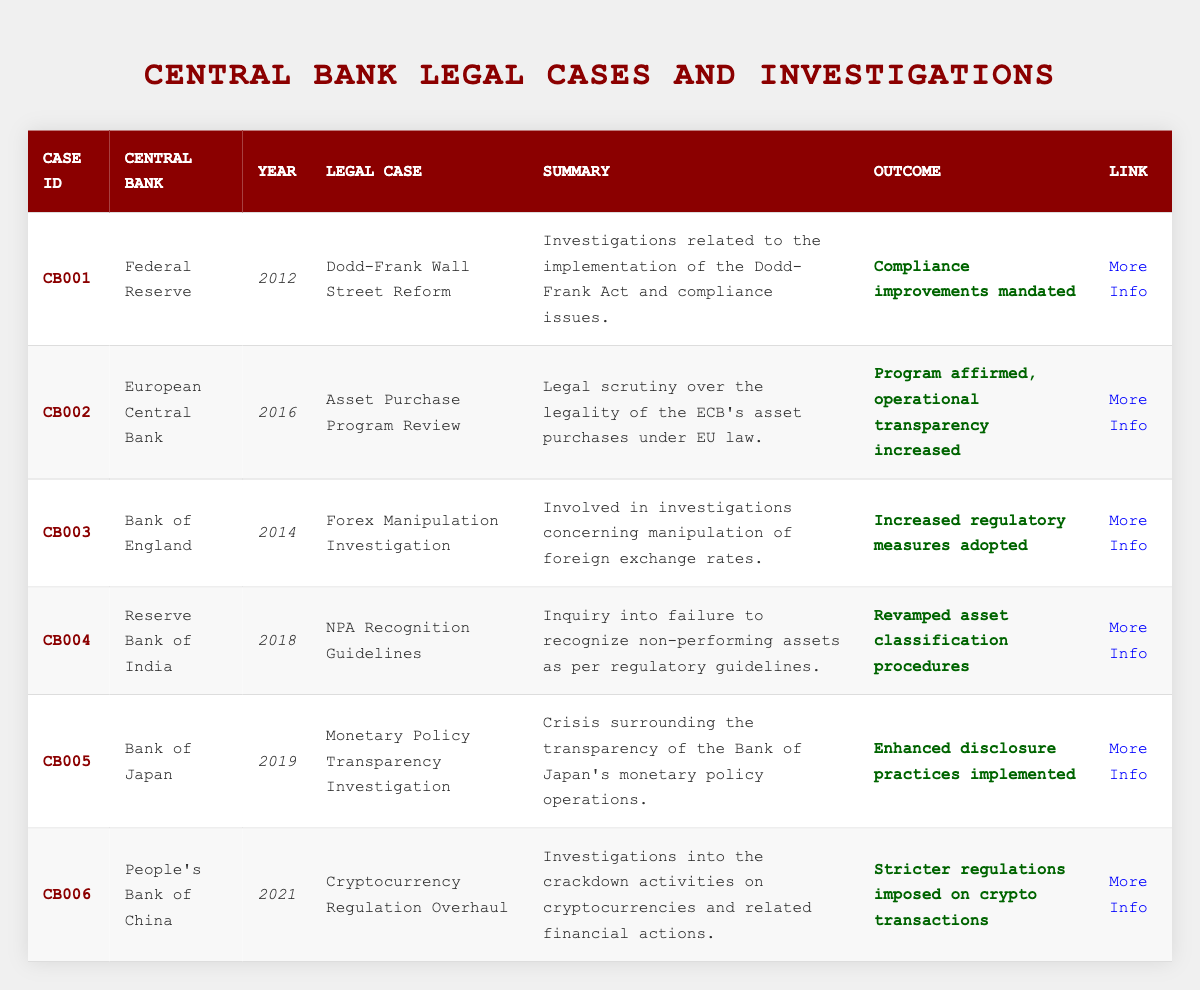What is the legal case associated with the Federal Reserve in 2012? The table lists the Federal Reserve's legal case in 2012 as "Dodd-Frank Wall Street Reform."
Answer: Dodd-Frank Wall Street Reform Which central bank had a legal case regarding Forex manipulation and in what year? According to the table, the Bank of England had a legal case concerning Forex manipulation in 2014.
Answer: Bank of England, 2014 What was the outcome of the investigations for the Asset Purchase Program Review by the European Central Bank? The outcome stated in the table for the Asset Purchase Program Review was "Program affirmed, operational transparency increased."
Answer: Program affirmed, operational transparency increased How many legal cases listed in the table involved the regulation of cryptocurrencies? The table contains one legal case pertaining to cryptocurrencies: the "Cryptocurrency Regulation Overhaul" by the People's Bank of China in 2021.
Answer: One Is the outcome of the Forex Manipulation Investigation related to compliance improvements? The table shows that the outcome of the Forex Manipulation Investigation was "Increased regulatory measures adopted," which is different from compliance improvements.
Answer: No Which central bank underwent an investigation that resulted in revamped asset classification procedures? The Reserve Bank of India is indicated in the table as having revamped asset classification procedures following their investigation in 2018.
Answer: Reserve Bank of India What years are represented in the legal cases in the table? The years listed for the legal cases are 2012, 2014, 2016, 2018, 2019, and 2021. By examining the year column, these values can be extracted.
Answer: 2012, 2014, 2016, 2018, 2019, 2021 Was there any case that led to enhanced disclosure practices? Yes, the "Monetary Policy Transparency Investigation" involving the Bank of Japan led to enhanced disclosure practices implemented, as noted in the table.
Answer: Yes What is the connection between the year 2019 and the Bank of Japan? The table indicates that in 2019, the Bank of Japan was involved in a legal case regarding the "Monetary Policy Transparency Investigation."
Answer: Monetary Policy Transparency Investigation Which legal case had the summary related to non-performing assets and which central bank was involved? The table provides the summary about non-performing assets related to the "NPA Recognition Guidelines," and it involved the Reserve Bank of India.
Answer: NPA Recognition Guidelines, Reserve Bank of India 